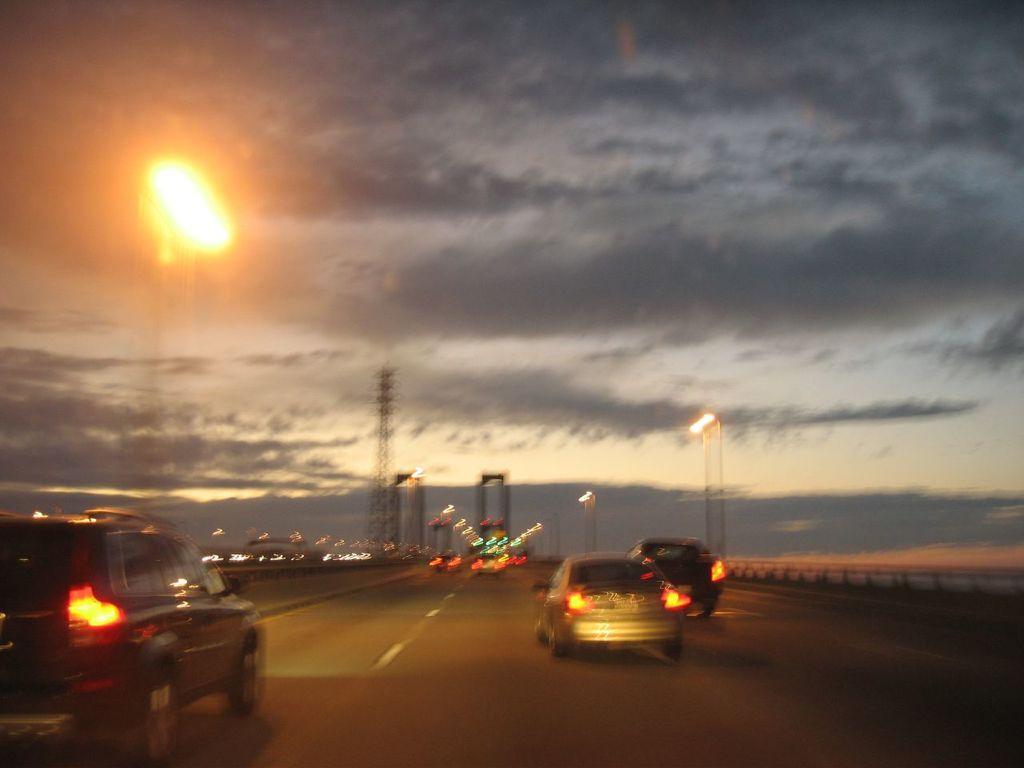Can you describe this image briefly? In this image we can see motor vehicles on the road, electric towers, electric lights, street poles, street lights and sky with clouds. 